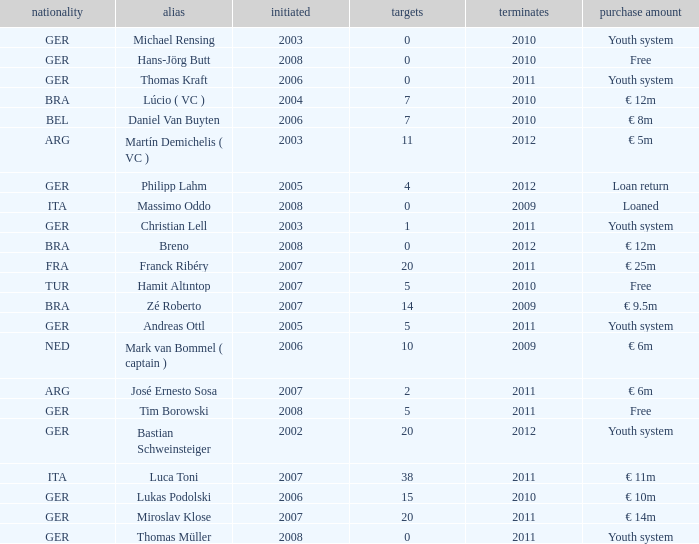What is the total number of ends after 2006 with a nationality of ita and 0 goals? 0.0. 